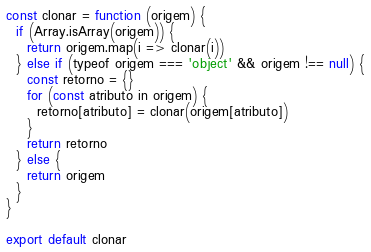<code> <loc_0><loc_0><loc_500><loc_500><_JavaScript_>const clonar = function (origem) {
  if (Array.isArray(origem)) {
    return origem.map(i => clonar(i))
  } else if (typeof origem === 'object' && origem !== null) {
    const retorno = {}
    for (const atributo in origem) {
      retorno[atributo] = clonar(origem[atributo])
    }
    return retorno
  } else {
    return origem
  }
}

export default clonar</code> 